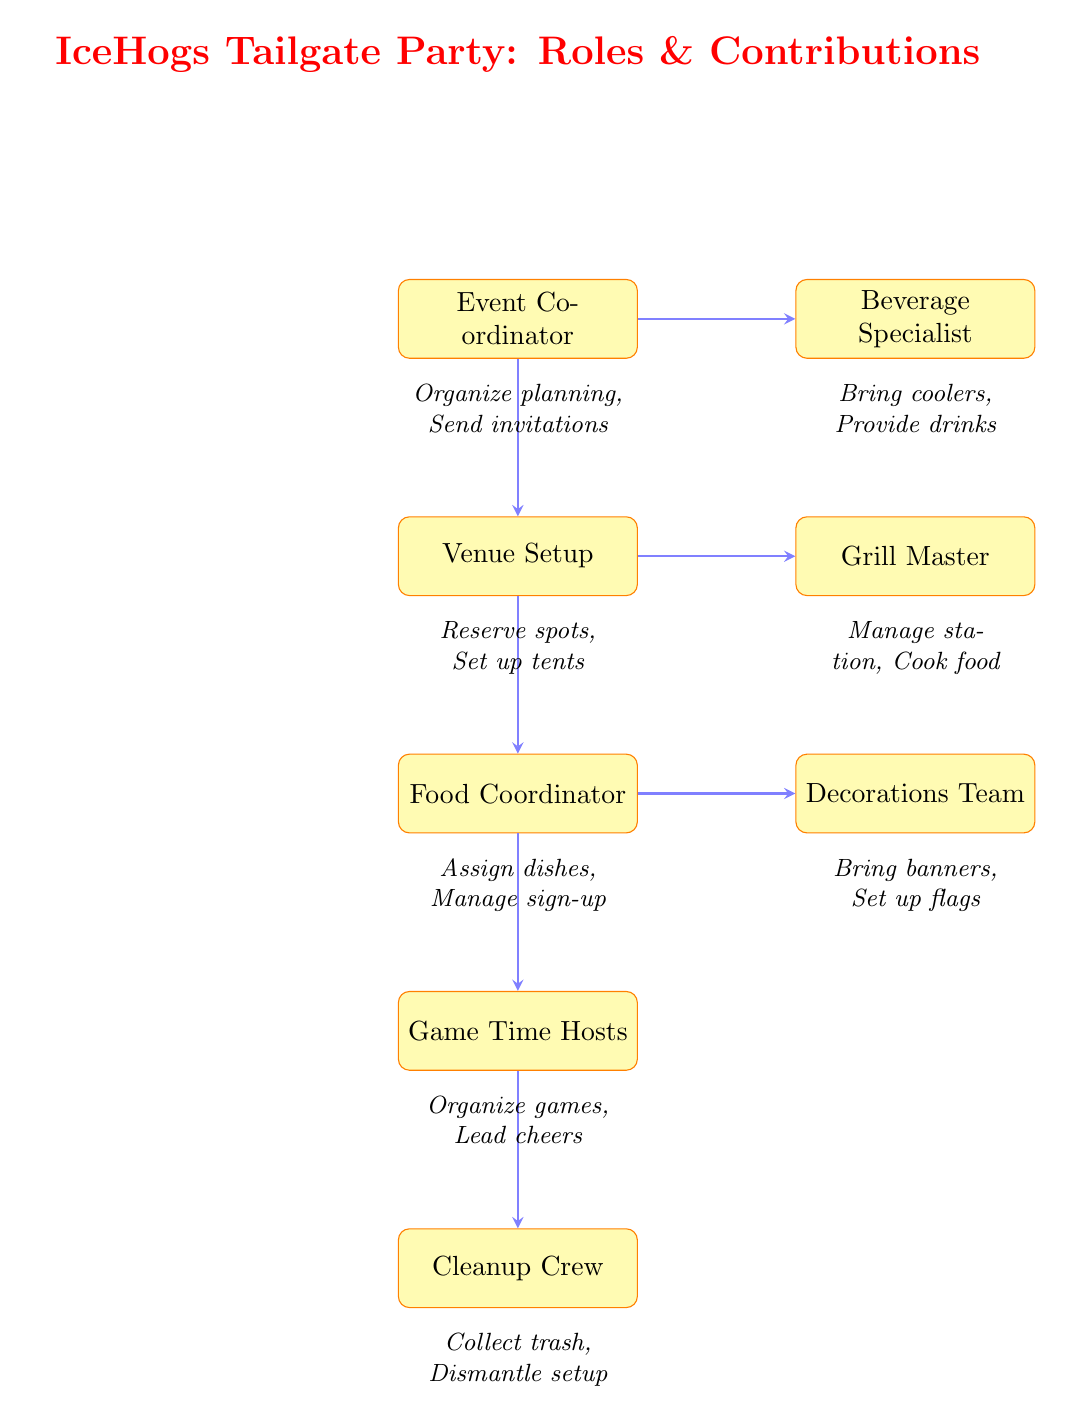What is the role of the individual responsible for organizing the planning meeting? The diagram indicates that the role responsible for organizing the planning meeting is the "Event Coordinator." This can be deduced by locating the "Event Coordinator" node at the top of the flowchart, which indicates they are the first step in the process.
Answer: Event Coordinator How many roles are connected to the "Food Coordinator"? To find the number of roles connected to the "Food Coordinator," we examine the arrows emanating from this node. From the diagram, the "Food Coordinator" has two outgoing arrows: one to "Game Time Hosts" and another to "Decorations Team." Therefore, there are two roles connected to the "Food Coordinator."
Answer: 2 What is the contribution of the "Grill Master"? The diagram provides a specific contribution for each role, and for the "Grill Master," the contribution outlined below the node is "Manage Grilling Station, Cook Hotdogs and Burgers." Therefore, the concise answer would be the actual text from that section.
Answer: Manage Grilling Station, Cook Hotdogs and Burgers Which role is responsible for collecting trash? By analyzing the diagram, the node labeled "Cleanup Crew" is the role tasked with collecting trash, as depicted by the arrow flowing down to this node from "Game Time Hosts." The information provided below this node states the contribution is "Collect Trash, Dismantle Setup."
Answer: Cleanup Crew Which role comes directly after the "Venue Setup" in the flow? The flow of the diagram shows that directly beneath the "Venue Setup" node is the "Food Coordinator." Therefore, this is the role that immediately follows "Venue Setup" as indicated by the vertical arrangement of the nodes.
Answer: Food Coordinator What are the two distinct tasks assigned to the "Beverage Specialist"? The diagram specifies that the contributions of the "Beverage Specialist" include "Bring Coolers" and "Provide Assorted Drinks." This information can be gathered by reviewing the description located directly below the "Beverage Specialist" node.
Answer: Bring Coolers, Provide Assorted Drinks 